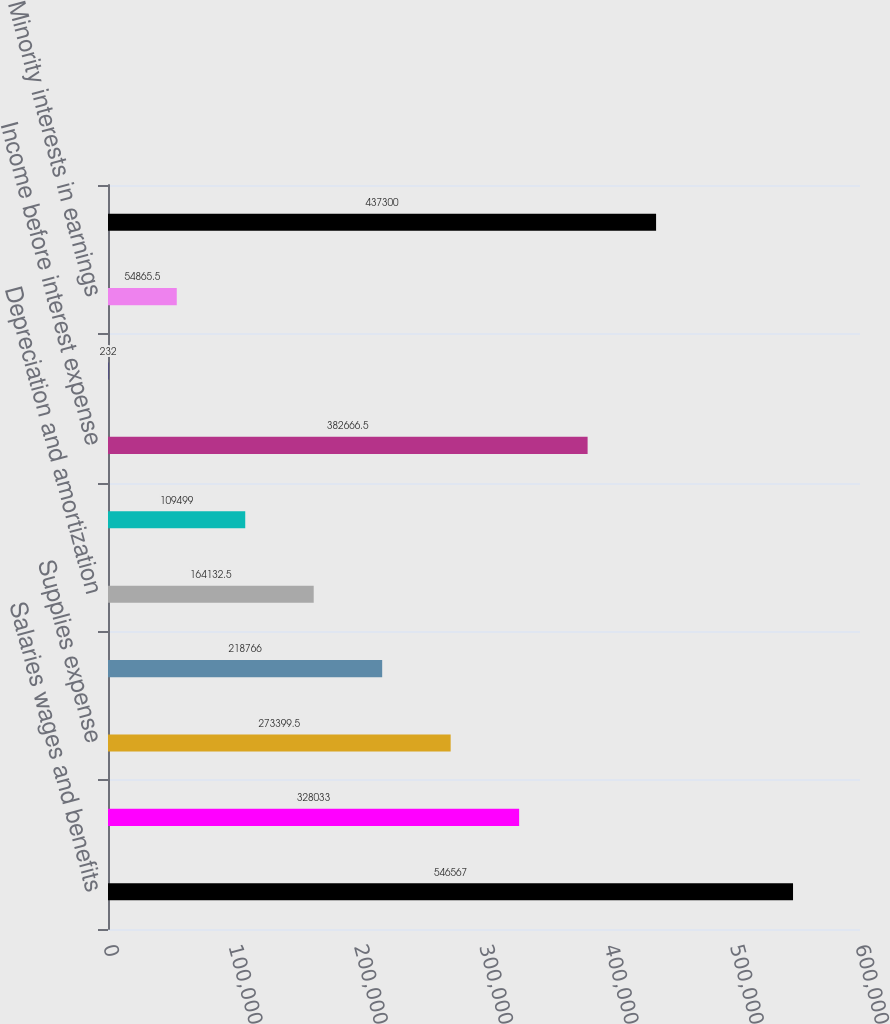<chart> <loc_0><loc_0><loc_500><loc_500><bar_chart><fcel>Salaries wages and benefits<fcel>Other operating expenses<fcel>Supplies expense<fcel>Provision for doubtful<fcel>Depreciation and amortization<fcel>Lease and rental expense<fcel>Income before interest expense<fcel>Interest expense net<fcel>Minority interests in earnings<fcel>Income before income taxes<nl><fcel>546567<fcel>328033<fcel>273400<fcel>218766<fcel>164132<fcel>109499<fcel>382666<fcel>232<fcel>54865.5<fcel>437300<nl></chart> 